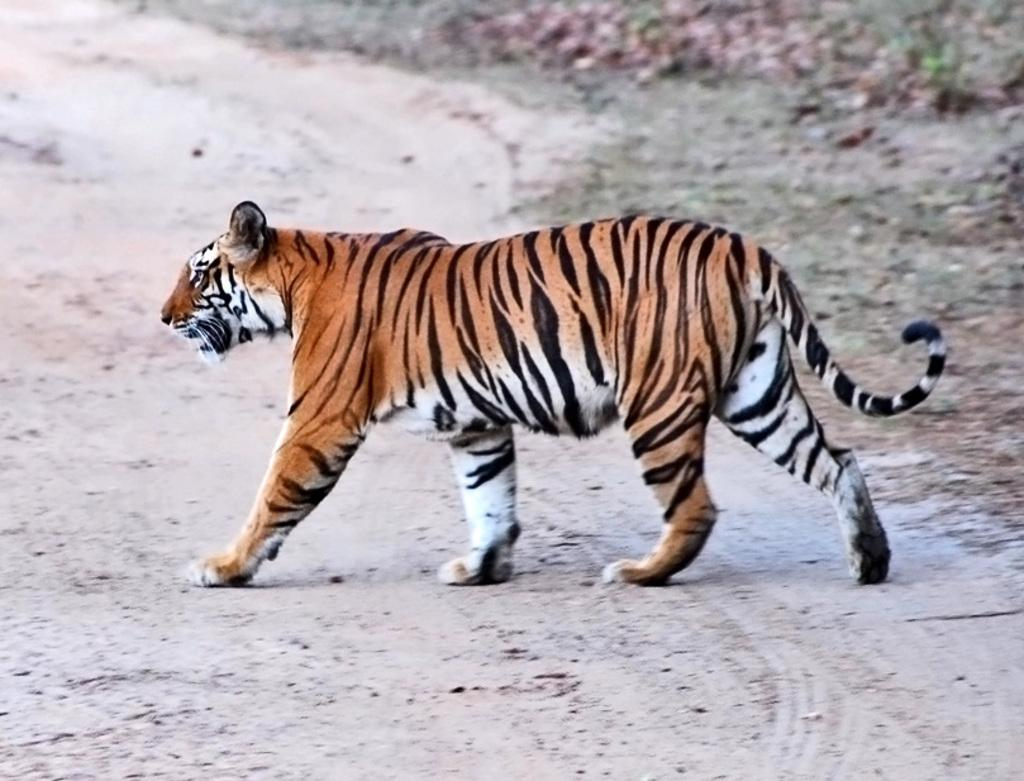What type of creature is present in the image? There is an animal in the image. Where is the animal located? The animal is on the ground. Can you describe the background of the image? The background of the image is blurred. What color is the curtain hanging behind the animal in the image? There is no curtain present in the image. How many chickens are visible in the image? There are no chickens present in the image. 